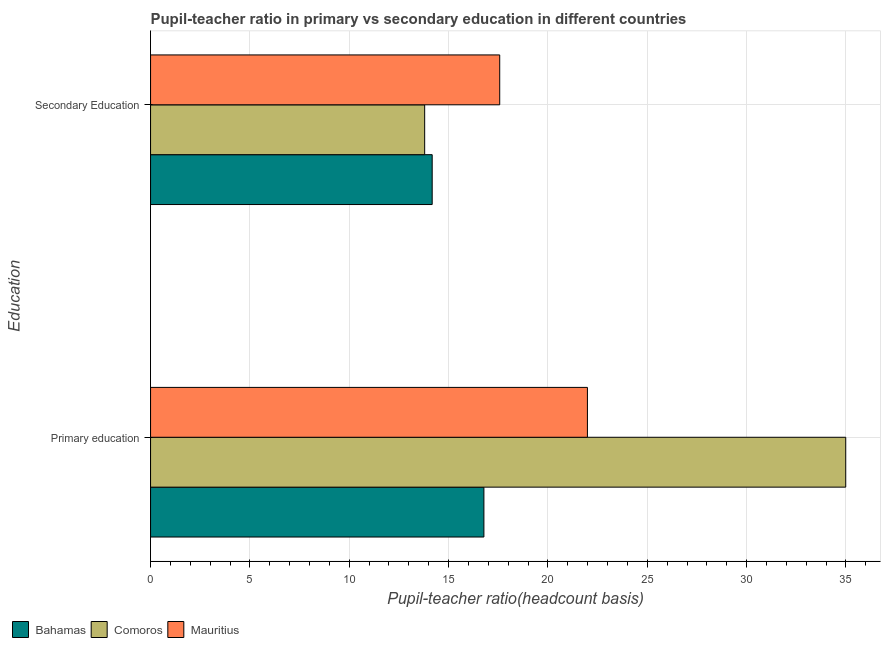Are the number of bars per tick equal to the number of legend labels?
Your response must be concise. Yes. Are the number of bars on each tick of the Y-axis equal?
Provide a short and direct response. Yes. How many bars are there on the 1st tick from the bottom?
Ensure brevity in your answer.  3. What is the pupil-teacher ratio in primary education in Mauritius?
Offer a very short reply. 21.99. Across all countries, what is the maximum pupil teacher ratio on secondary education?
Provide a short and direct response. 17.57. Across all countries, what is the minimum pupil teacher ratio on secondary education?
Make the answer very short. 13.8. In which country was the pupil teacher ratio on secondary education maximum?
Offer a terse response. Mauritius. In which country was the pupil-teacher ratio in primary education minimum?
Your response must be concise. Bahamas. What is the total pupil teacher ratio on secondary education in the graph?
Offer a very short reply. 45.54. What is the difference between the pupil-teacher ratio in primary education in Mauritius and that in Bahamas?
Your response must be concise. 5.21. What is the difference between the pupil teacher ratio on secondary education in Comoros and the pupil-teacher ratio in primary education in Mauritius?
Ensure brevity in your answer.  -8.19. What is the average pupil teacher ratio on secondary education per country?
Give a very brief answer. 15.18. What is the difference between the pupil teacher ratio on secondary education and pupil-teacher ratio in primary education in Bahamas?
Your answer should be compact. -2.6. In how many countries, is the pupil teacher ratio on secondary education greater than 28 ?
Your response must be concise. 0. What is the ratio of the pupil-teacher ratio in primary education in Bahamas to that in Comoros?
Ensure brevity in your answer.  0.48. In how many countries, is the pupil-teacher ratio in primary education greater than the average pupil-teacher ratio in primary education taken over all countries?
Offer a very short reply. 1. What does the 1st bar from the top in Primary education represents?
Provide a short and direct response. Mauritius. What does the 1st bar from the bottom in Secondary Education represents?
Provide a succinct answer. Bahamas. Are all the bars in the graph horizontal?
Your response must be concise. Yes. How many legend labels are there?
Your answer should be compact. 3. What is the title of the graph?
Offer a terse response. Pupil-teacher ratio in primary vs secondary education in different countries. What is the label or title of the X-axis?
Your answer should be compact. Pupil-teacher ratio(headcount basis). What is the label or title of the Y-axis?
Keep it short and to the point. Education. What is the Pupil-teacher ratio(headcount basis) in Bahamas in Primary education?
Your response must be concise. 16.78. What is the Pupil-teacher ratio(headcount basis) of Comoros in Primary education?
Provide a short and direct response. 34.99. What is the Pupil-teacher ratio(headcount basis) in Mauritius in Primary education?
Ensure brevity in your answer.  21.99. What is the Pupil-teacher ratio(headcount basis) in Bahamas in Secondary Education?
Provide a succinct answer. 14.17. What is the Pupil-teacher ratio(headcount basis) in Comoros in Secondary Education?
Ensure brevity in your answer.  13.8. What is the Pupil-teacher ratio(headcount basis) in Mauritius in Secondary Education?
Provide a succinct answer. 17.57. Across all Education, what is the maximum Pupil-teacher ratio(headcount basis) of Bahamas?
Your response must be concise. 16.78. Across all Education, what is the maximum Pupil-teacher ratio(headcount basis) in Comoros?
Offer a very short reply. 34.99. Across all Education, what is the maximum Pupil-teacher ratio(headcount basis) in Mauritius?
Your answer should be very brief. 21.99. Across all Education, what is the minimum Pupil-teacher ratio(headcount basis) of Bahamas?
Your answer should be compact. 14.17. Across all Education, what is the minimum Pupil-teacher ratio(headcount basis) of Comoros?
Your response must be concise. 13.8. Across all Education, what is the minimum Pupil-teacher ratio(headcount basis) of Mauritius?
Offer a terse response. 17.57. What is the total Pupil-teacher ratio(headcount basis) of Bahamas in the graph?
Give a very brief answer. 30.95. What is the total Pupil-teacher ratio(headcount basis) in Comoros in the graph?
Your answer should be compact. 48.78. What is the total Pupil-teacher ratio(headcount basis) in Mauritius in the graph?
Make the answer very short. 39.56. What is the difference between the Pupil-teacher ratio(headcount basis) in Bahamas in Primary education and that in Secondary Education?
Give a very brief answer. 2.6. What is the difference between the Pupil-teacher ratio(headcount basis) of Comoros in Primary education and that in Secondary Education?
Offer a terse response. 21.19. What is the difference between the Pupil-teacher ratio(headcount basis) in Mauritius in Primary education and that in Secondary Education?
Offer a very short reply. 4.41. What is the difference between the Pupil-teacher ratio(headcount basis) in Bahamas in Primary education and the Pupil-teacher ratio(headcount basis) in Comoros in Secondary Education?
Make the answer very short. 2.98. What is the difference between the Pupil-teacher ratio(headcount basis) in Bahamas in Primary education and the Pupil-teacher ratio(headcount basis) in Mauritius in Secondary Education?
Provide a short and direct response. -0.8. What is the difference between the Pupil-teacher ratio(headcount basis) in Comoros in Primary education and the Pupil-teacher ratio(headcount basis) in Mauritius in Secondary Education?
Give a very brief answer. 17.41. What is the average Pupil-teacher ratio(headcount basis) in Bahamas per Education?
Keep it short and to the point. 15.48. What is the average Pupil-teacher ratio(headcount basis) in Comoros per Education?
Your answer should be compact. 24.39. What is the average Pupil-teacher ratio(headcount basis) in Mauritius per Education?
Give a very brief answer. 19.78. What is the difference between the Pupil-teacher ratio(headcount basis) of Bahamas and Pupil-teacher ratio(headcount basis) of Comoros in Primary education?
Ensure brevity in your answer.  -18.21. What is the difference between the Pupil-teacher ratio(headcount basis) of Bahamas and Pupil-teacher ratio(headcount basis) of Mauritius in Primary education?
Provide a succinct answer. -5.21. What is the difference between the Pupil-teacher ratio(headcount basis) in Comoros and Pupil-teacher ratio(headcount basis) in Mauritius in Primary education?
Provide a succinct answer. 13. What is the difference between the Pupil-teacher ratio(headcount basis) of Bahamas and Pupil-teacher ratio(headcount basis) of Comoros in Secondary Education?
Provide a succinct answer. 0.38. What is the difference between the Pupil-teacher ratio(headcount basis) of Bahamas and Pupil-teacher ratio(headcount basis) of Mauritius in Secondary Education?
Your answer should be compact. -3.4. What is the difference between the Pupil-teacher ratio(headcount basis) of Comoros and Pupil-teacher ratio(headcount basis) of Mauritius in Secondary Education?
Offer a terse response. -3.78. What is the ratio of the Pupil-teacher ratio(headcount basis) in Bahamas in Primary education to that in Secondary Education?
Make the answer very short. 1.18. What is the ratio of the Pupil-teacher ratio(headcount basis) of Comoros in Primary education to that in Secondary Education?
Your answer should be very brief. 2.54. What is the ratio of the Pupil-teacher ratio(headcount basis) in Mauritius in Primary education to that in Secondary Education?
Your response must be concise. 1.25. What is the difference between the highest and the second highest Pupil-teacher ratio(headcount basis) in Bahamas?
Make the answer very short. 2.6. What is the difference between the highest and the second highest Pupil-teacher ratio(headcount basis) in Comoros?
Keep it short and to the point. 21.19. What is the difference between the highest and the second highest Pupil-teacher ratio(headcount basis) of Mauritius?
Offer a very short reply. 4.41. What is the difference between the highest and the lowest Pupil-teacher ratio(headcount basis) of Bahamas?
Offer a very short reply. 2.6. What is the difference between the highest and the lowest Pupil-teacher ratio(headcount basis) of Comoros?
Your response must be concise. 21.19. What is the difference between the highest and the lowest Pupil-teacher ratio(headcount basis) of Mauritius?
Offer a very short reply. 4.41. 